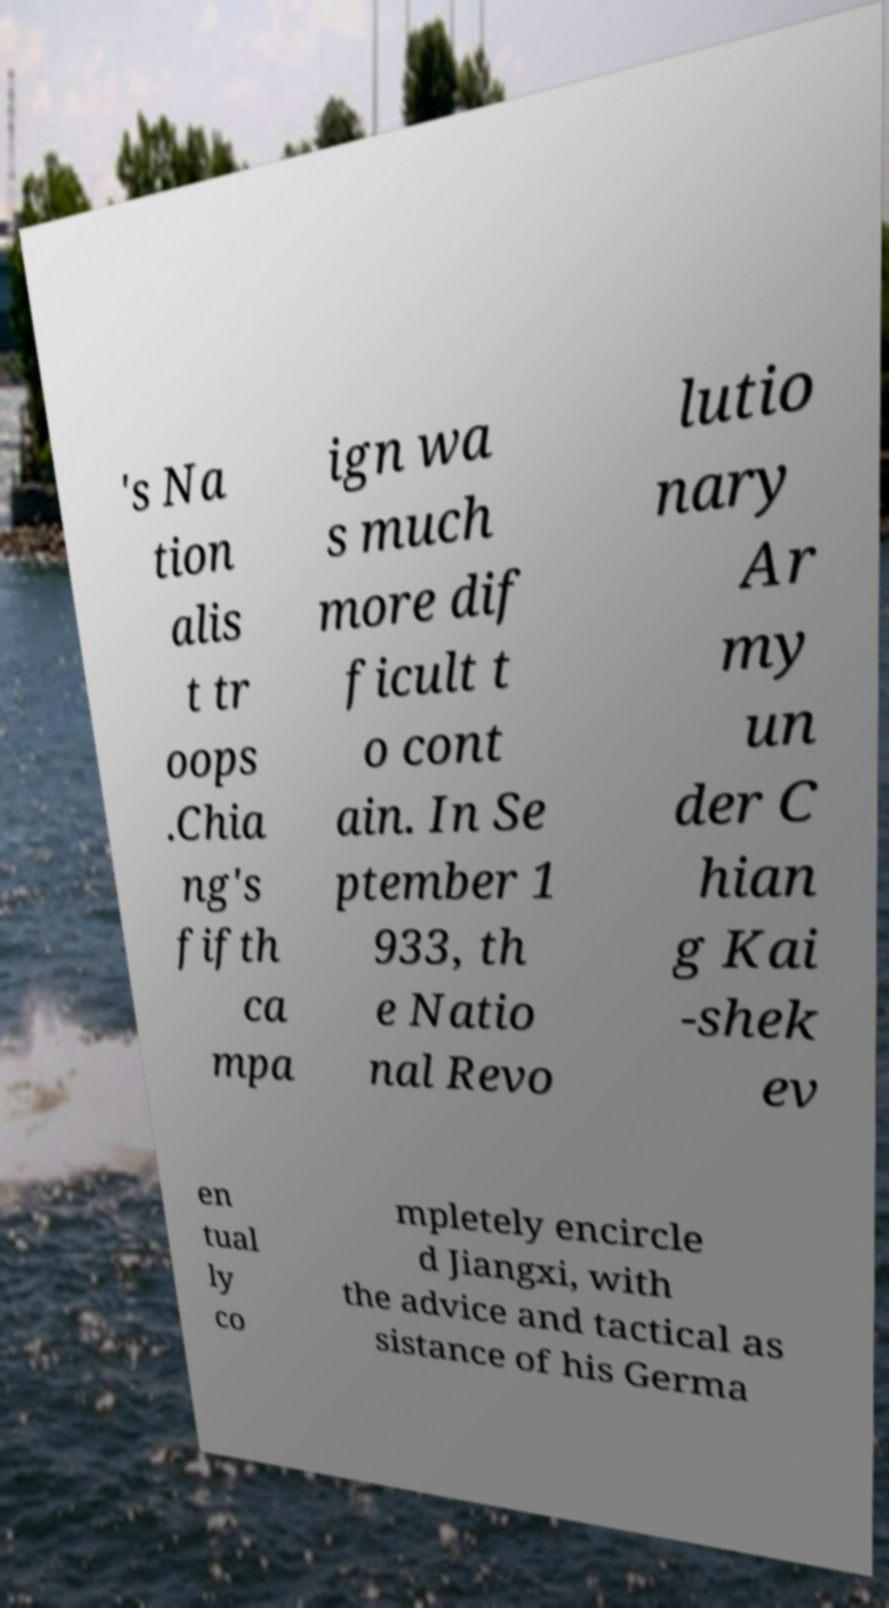I need the written content from this picture converted into text. Can you do that? 's Na tion alis t tr oops .Chia ng's fifth ca mpa ign wa s much more dif ficult t o cont ain. In Se ptember 1 933, th e Natio nal Revo lutio nary Ar my un der C hian g Kai -shek ev en tual ly co mpletely encircle d Jiangxi, with the advice and tactical as sistance of his Germa 